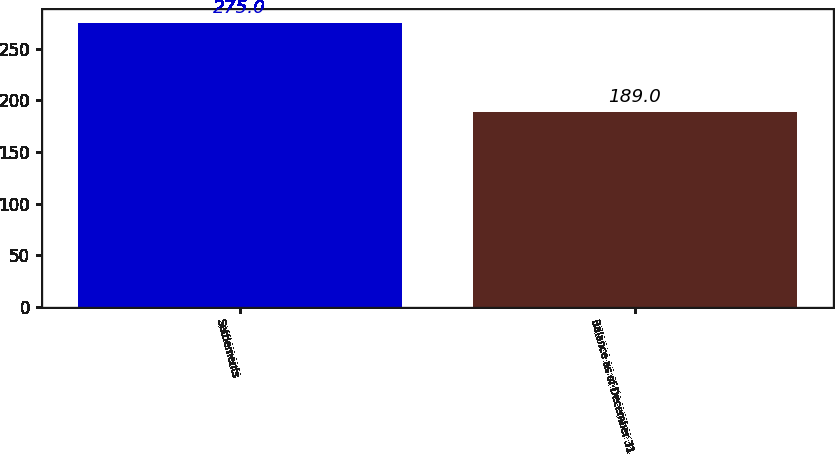Convert chart to OTSL. <chart><loc_0><loc_0><loc_500><loc_500><bar_chart><fcel>Settlements<fcel>Balance as of December 31<nl><fcel>275<fcel>189<nl></chart> 